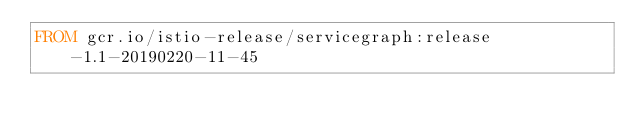<code> <loc_0><loc_0><loc_500><loc_500><_Dockerfile_>FROM gcr.io/istio-release/servicegraph:release-1.1-20190220-11-45
</code> 